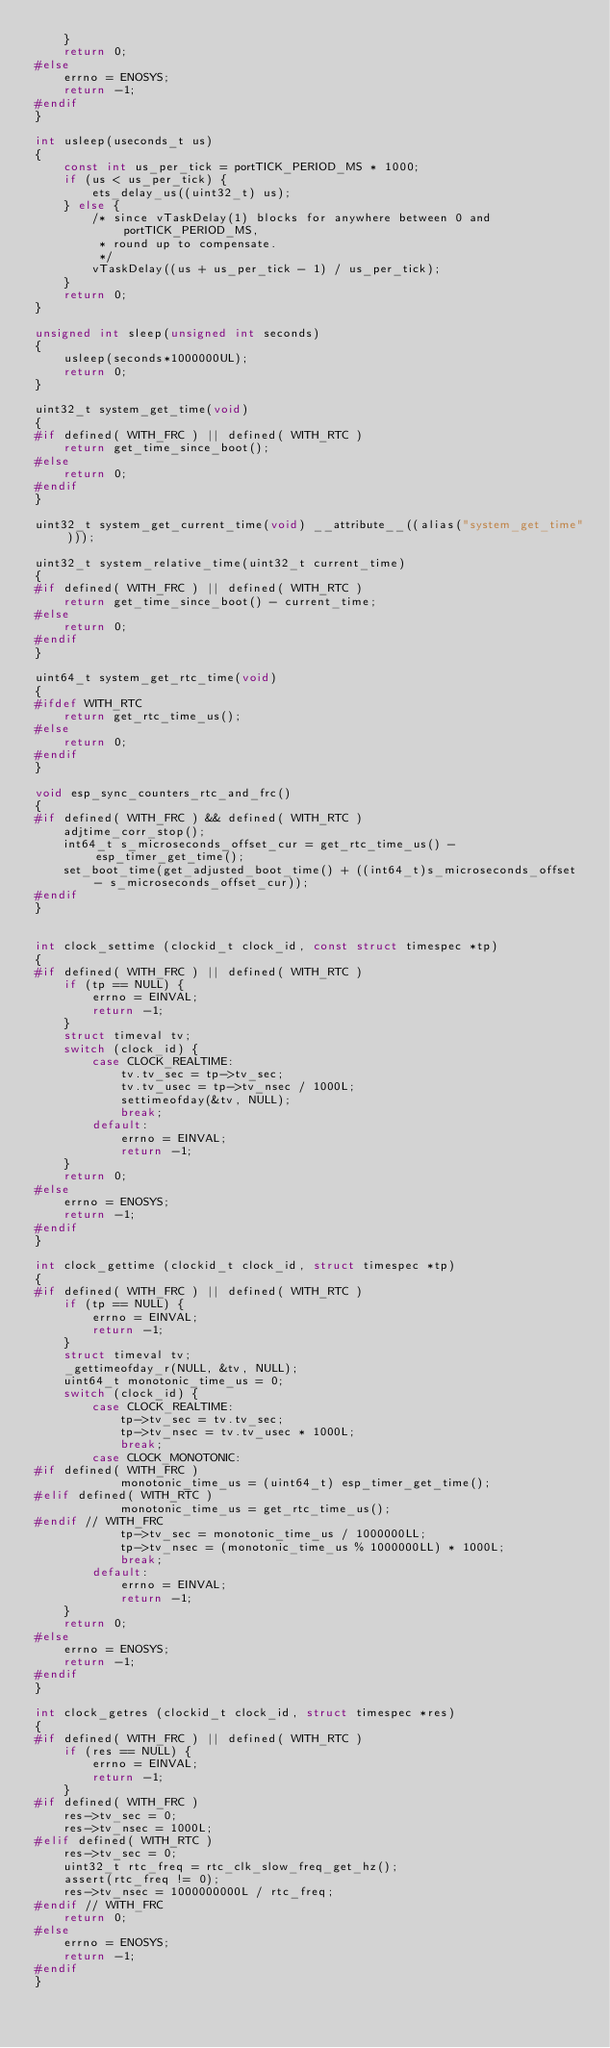<code> <loc_0><loc_0><loc_500><loc_500><_C_>    }
    return 0;
#else
    errno = ENOSYS;
    return -1;
#endif
}

int usleep(useconds_t us)
{
    const int us_per_tick = portTICK_PERIOD_MS * 1000;
    if (us < us_per_tick) {
        ets_delay_us((uint32_t) us);
    } else {
        /* since vTaskDelay(1) blocks for anywhere between 0 and portTICK_PERIOD_MS,
         * round up to compensate.
         */
        vTaskDelay((us + us_per_tick - 1) / us_per_tick);
    }
    return 0;
}

unsigned int sleep(unsigned int seconds)
{
    usleep(seconds*1000000UL);
    return 0;
}

uint32_t system_get_time(void)
{
#if defined( WITH_FRC ) || defined( WITH_RTC )
    return get_time_since_boot();
#else
    return 0;
#endif
}

uint32_t system_get_current_time(void) __attribute__((alias("system_get_time")));

uint32_t system_relative_time(uint32_t current_time)
{
#if defined( WITH_FRC ) || defined( WITH_RTC )
    return get_time_since_boot() - current_time;
#else
    return 0;
#endif
}

uint64_t system_get_rtc_time(void)
{
#ifdef WITH_RTC
    return get_rtc_time_us();
#else
    return 0;
#endif
}

void esp_sync_counters_rtc_and_frc()
{
#if defined( WITH_FRC ) && defined( WITH_RTC )
    adjtime_corr_stop();
    int64_t s_microseconds_offset_cur = get_rtc_time_us() - esp_timer_get_time();
    set_boot_time(get_adjusted_boot_time() + ((int64_t)s_microseconds_offset - s_microseconds_offset_cur));
#endif
}


int clock_settime (clockid_t clock_id, const struct timespec *tp)
{
#if defined( WITH_FRC ) || defined( WITH_RTC )
    if (tp == NULL) {
        errno = EINVAL;
        return -1;
    }
    struct timeval tv;
    switch (clock_id) {
        case CLOCK_REALTIME:
            tv.tv_sec = tp->tv_sec;
            tv.tv_usec = tp->tv_nsec / 1000L;
            settimeofday(&tv, NULL);
            break;
        default:
            errno = EINVAL;
            return -1;
    }
    return 0;
#else
    errno = ENOSYS;
    return -1;
#endif
}

int clock_gettime (clockid_t clock_id, struct timespec *tp)
{
#if defined( WITH_FRC ) || defined( WITH_RTC )
    if (tp == NULL) {
        errno = EINVAL;
        return -1;
    }
    struct timeval tv;
    _gettimeofday_r(NULL, &tv, NULL);
    uint64_t monotonic_time_us = 0;
    switch (clock_id) {
        case CLOCK_REALTIME:
            tp->tv_sec = tv.tv_sec;
            tp->tv_nsec = tv.tv_usec * 1000L;
            break;
        case CLOCK_MONOTONIC:
#if defined( WITH_FRC )
            monotonic_time_us = (uint64_t) esp_timer_get_time();
#elif defined( WITH_RTC )
            monotonic_time_us = get_rtc_time_us();
#endif // WITH_FRC
            tp->tv_sec = monotonic_time_us / 1000000LL;
            tp->tv_nsec = (monotonic_time_us % 1000000LL) * 1000L;
            break;
        default:
            errno = EINVAL;
            return -1;
    }
    return 0;
#else
    errno = ENOSYS;
    return -1;
#endif
}

int clock_getres (clockid_t clock_id, struct timespec *res)
{
#if defined( WITH_FRC ) || defined( WITH_RTC )
    if (res == NULL) {
        errno = EINVAL;
        return -1;
    }
#if defined( WITH_FRC )
    res->tv_sec = 0;
    res->tv_nsec = 1000L;
#elif defined( WITH_RTC )
    res->tv_sec = 0;
    uint32_t rtc_freq = rtc_clk_slow_freq_get_hz();
    assert(rtc_freq != 0);
    res->tv_nsec = 1000000000L / rtc_freq;
#endif // WITH_FRC
    return 0;
#else
    errno = ENOSYS;
    return -1;
#endif
}
</code> 